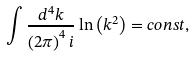<formula> <loc_0><loc_0><loc_500><loc_500>\int \frac { d ^ { 4 } k } { \left ( 2 \pi \right ) ^ { 4 } i } \ln \left ( k ^ { 2 } \right ) = c o n s t ,</formula> 